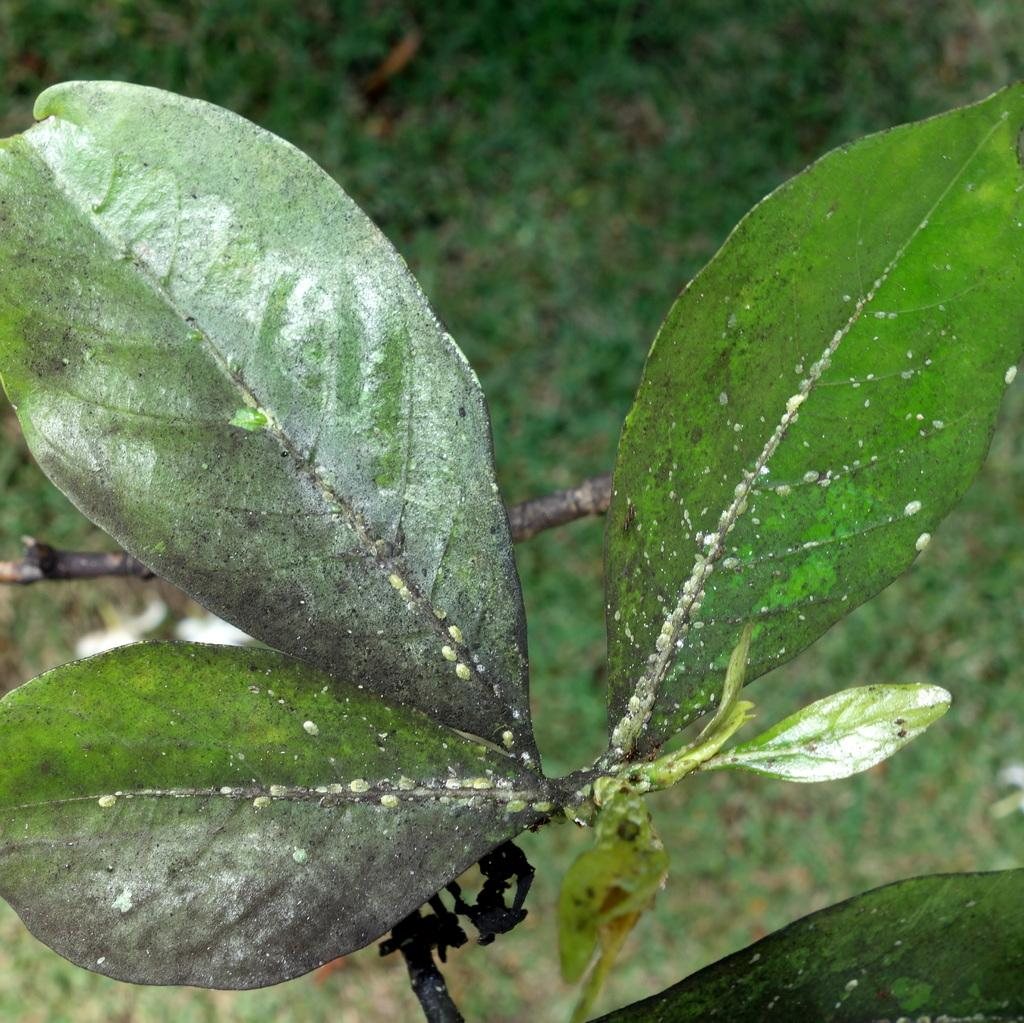What type of vegetation can be seen in the image? There are leaves on a branch in the image. What type of wine is being served in the image? There is no wine present in the image; it only features leaves on a branch. 